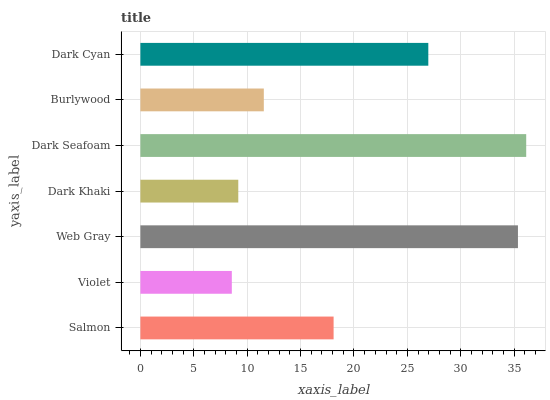Is Violet the minimum?
Answer yes or no. Yes. Is Dark Seafoam the maximum?
Answer yes or no. Yes. Is Web Gray the minimum?
Answer yes or no. No. Is Web Gray the maximum?
Answer yes or no. No. Is Web Gray greater than Violet?
Answer yes or no. Yes. Is Violet less than Web Gray?
Answer yes or no. Yes. Is Violet greater than Web Gray?
Answer yes or no. No. Is Web Gray less than Violet?
Answer yes or no. No. Is Salmon the high median?
Answer yes or no. Yes. Is Salmon the low median?
Answer yes or no. Yes. Is Burlywood the high median?
Answer yes or no. No. Is Burlywood the low median?
Answer yes or no. No. 